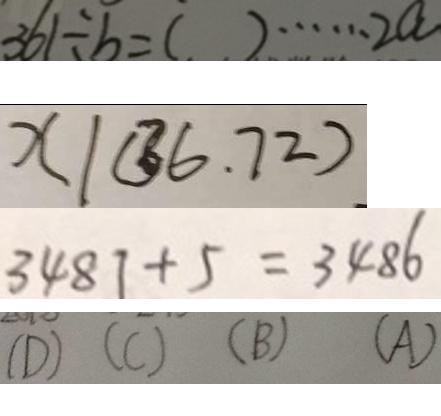<formula> <loc_0><loc_0><loc_500><loc_500>3 6 1 \div b = ( ) \cdots 2 a 
 x \vert ( 3 6 . 7 2 ) . 
 3 4 8 1 + 5 = 3 4 8 6 
 ( D ) ( C ) ( B ) ( A )</formula> 